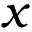Convert formula to latex. <formula><loc_0><loc_0><loc_500><loc_500>x</formula> 